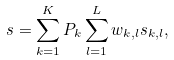Convert formula to latex. <formula><loc_0><loc_0><loc_500><loc_500>s = \sum ^ { K } _ { k = 1 } P _ { k } \sum ^ { L } _ { l = 1 } w _ { k , l } s _ { k , l } ,</formula> 